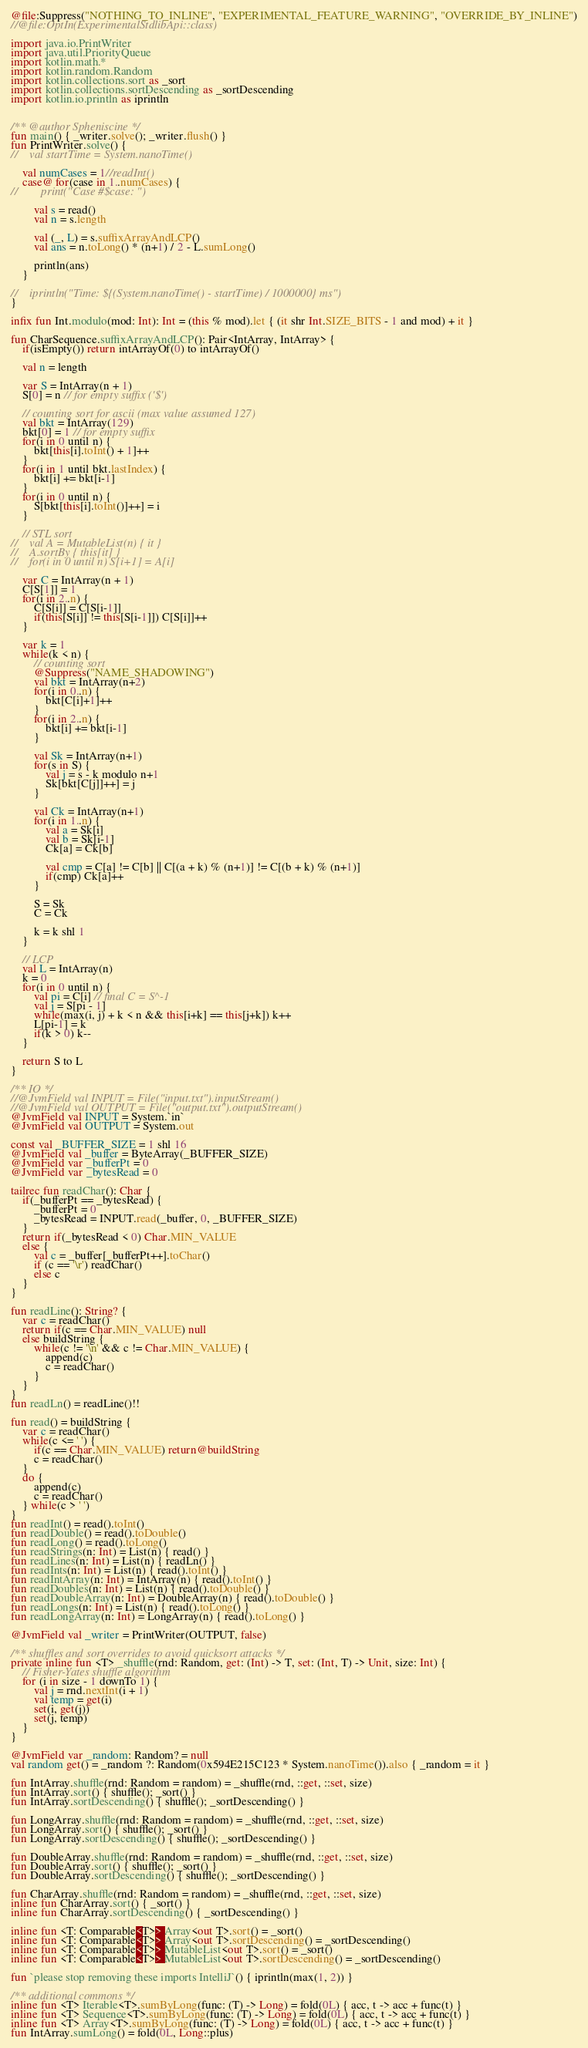<code> <loc_0><loc_0><loc_500><loc_500><_Kotlin_>@file:Suppress("NOTHING_TO_INLINE", "EXPERIMENTAL_FEATURE_WARNING", "OVERRIDE_BY_INLINE")
//@file:OptIn(ExperimentalStdlibApi::class)

import java.io.PrintWriter
import java.util.PriorityQueue
import kotlin.math.*
import kotlin.random.Random
import kotlin.collections.sort as _sort
import kotlin.collections.sortDescending as _sortDescending
import kotlin.io.println as iprintln


/** @author Spheniscine */
fun main() { _writer.solve(); _writer.flush() }
fun PrintWriter.solve() {
//    val startTime = System.nanoTime()

    val numCases = 1//readInt()
    case@ for(case in 1..numCases) {
//        print("Case #$case: ")

        val s = read()
        val n = s.length

        val (_, L) = s.suffixArrayAndLCP()
        val ans = n.toLong() * (n+1) / 2 - L.sumLong()

        println(ans)
    }

//    iprintln("Time: ${(System.nanoTime() - startTime) / 1000000} ms")
}

infix fun Int.modulo(mod: Int): Int = (this % mod).let { (it shr Int.SIZE_BITS - 1 and mod) + it }

fun CharSequence.suffixArrayAndLCP(): Pair<IntArray, IntArray> {
    if(isEmpty()) return intArrayOf(0) to intArrayOf()

    val n = length

    var S = IntArray(n + 1)
    S[0] = n // for empty suffix ('$')

    // counting sort for ascii (max value assumed 127)
    val bkt = IntArray(129)
    bkt[0] = 1 // for empty suffix
    for(i in 0 until n) {
        bkt[this[i].toInt() + 1]++
    }
    for(i in 1 until bkt.lastIndex) {
        bkt[i] += bkt[i-1]
    }
    for(i in 0 until n) {
        S[bkt[this[i].toInt()]++] = i
    }

    // STL sort
//    val A = MutableList(n) { it }
//    A.sortBy { this[it] }
//    for(i in 0 until n) S[i+1] = A[i]

    var C = IntArray(n + 1)
    C[S[1]] = 1
    for(i in 2..n) {
        C[S[i]] = C[S[i-1]]
        if(this[S[i]] != this[S[i-1]]) C[S[i]]++
    }

    var k = 1
    while(k < n) {
        // counting sort
        @Suppress("NAME_SHADOWING")
        val bkt = IntArray(n+2)
        for(i in 0..n) {
            bkt[C[i]+1]++
        }
        for(i in 2..n) {
            bkt[i] += bkt[i-1]
        }

        val Sk = IntArray(n+1)
        for(s in S) {
            val j = s - k modulo n+1
            Sk[bkt[C[j]]++] = j
        }

        val Ck = IntArray(n+1)
        for(i in 1..n) {
            val a = Sk[i]
            val b = Sk[i-1]
            Ck[a] = Ck[b]

            val cmp = C[a] != C[b] || C[(a + k) % (n+1)] != C[(b + k) % (n+1)]
            if(cmp) Ck[a]++
        }

        S = Sk
        C = Ck

        k = k shl 1
    }

    // LCP
    val L = IntArray(n)
    k = 0
    for(i in 0 until n) {
        val pi = C[i] // final C = S^-1
        val j = S[pi - 1]
        while(max(i, j) + k < n && this[i+k] == this[j+k]) k++
        L[pi-1] = k
        if(k > 0) k--
    }

    return S to L
}

/** IO */
//@JvmField val INPUT = File("input.txt").inputStream()
//@JvmField val OUTPUT = File("output.txt").outputStream()
@JvmField val INPUT = System.`in`
@JvmField val OUTPUT = System.out

const val _BUFFER_SIZE = 1 shl 16
@JvmField val _buffer = ByteArray(_BUFFER_SIZE)
@JvmField var _bufferPt = 0
@JvmField var _bytesRead = 0

tailrec fun readChar(): Char {
    if(_bufferPt == _bytesRead) {
        _bufferPt = 0
        _bytesRead = INPUT.read(_buffer, 0, _BUFFER_SIZE)
    }
    return if(_bytesRead < 0) Char.MIN_VALUE
    else {
        val c = _buffer[_bufferPt++].toChar()
        if (c == '\r') readChar()
        else c
    }
}

fun readLine(): String? {
    var c = readChar()
    return if(c == Char.MIN_VALUE) null
    else buildString {
        while(c != '\n' && c != Char.MIN_VALUE) {
            append(c)
            c = readChar()
        }
    }
}
fun readLn() = readLine()!!

fun read() = buildString {
    var c = readChar()
    while(c <= ' ') {
        if(c == Char.MIN_VALUE) return@buildString
        c = readChar()
    }
    do {
        append(c)
        c = readChar()
    } while(c > ' ')
}
fun readInt() = read().toInt()
fun readDouble() = read().toDouble()
fun readLong() = read().toLong()
fun readStrings(n: Int) = List(n) { read() }
fun readLines(n: Int) = List(n) { readLn() }
fun readInts(n: Int) = List(n) { read().toInt() }
fun readIntArray(n: Int) = IntArray(n) { read().toInt() }
fun readDoubles(n: Int) = List(n) { read().toDouble() }
fun readDoubleArray(n: Int) = DoubleArray(n) { read().toDouble() }
fun readLongs(n: Int) = List(n) { read().toLong() }
fun readLongArray(n: Int) = LongArray(n) { read().toLong() }

@JvmField val _writer = PrintWriter(OUTPUT, false)

/** shuffles and sort overrides to avoid quicksort attacks */
private inline fun <T> _shuffle(rnd: Random, get: (Int) -> T, set: (Int, T) -> Unit, size: Int) {
    // Fisher-Yates shuffle algorithm
    for (i in size - 1 downTo 1) {
        val j = rnd.nextInt(i + 1)
        val temp = get(i)
        set(i, get(j))
        set(j, temp)
    }
}

@JvmField var _random: Random? = null
val random get() = _random ?: Random(0x594E215C123 * System.nanoTime()).also { _random = it }

fun IntArray.shuffle(rnd: Random = random) = _shuffle(rnd, ::get, ::set, size)
fun IntArray.sort() { shuffle(); _sort() }
fun IntArray.sortDescending() { shuffle(); _sortDescending() }

fun LongArray.shuffle(rnd: Random = random) = _shuffle(rnd, ::get, ::set, size)
fun LongArray.sort() { shuffle(); _sort() }
fun LongArray.sortDescending() { shuffle(); _sortDescending() }

fun DoubleArray.shuffle(rnd: Random = random) = _shuffle(rnd, ::get, ::set, size)
fun DoubleArray.sort() { shuffle(); _sort() }
fun DoubleArray.sortDescending() { shuffle(); _sortDescending() }

fun CharArray.shuffle(rnd: Random = random) = _shuffle(rnd, ::get, ::set, size)
inline fun CharArray.sort() { _sort() }
inline fun CharArray.sortDescending() { _sortDescending() }

inline fun <T: Comparable<T>> Array<out T>.sort() = _sort()
inline fun <T: Comparable<T>> Array<out T>.sortDescending() = _sortDescending()
inline fun <T: Comparable<T>> MutableList<out T>.sort() = _sort()
inline fun <T: Comparable<T>> MutableList<out T>.sortDescending() = _sortDescending()

fun `please stop removing these imports IntelliJ`() { iprintln(max(1, 2)) }

/** additional commons */
inline fun <T> Iterable<T>.sumByLong(func: (T) -> Long) = fold(0L) { acc, t -> acc + func(t) }
inline fun <T> Sequence<T>.sumByLong(func: (T) -> Long) = fold(0L) { acc, t -> acc + func(t) }
inline fun <T> Array<T>.sumByLong(func: (T) -> Long) = fold(0L) { acc, t -> acc + func(t) }
fun IntArray.sumLong() = fold(0L, Long::plus)
</code> 